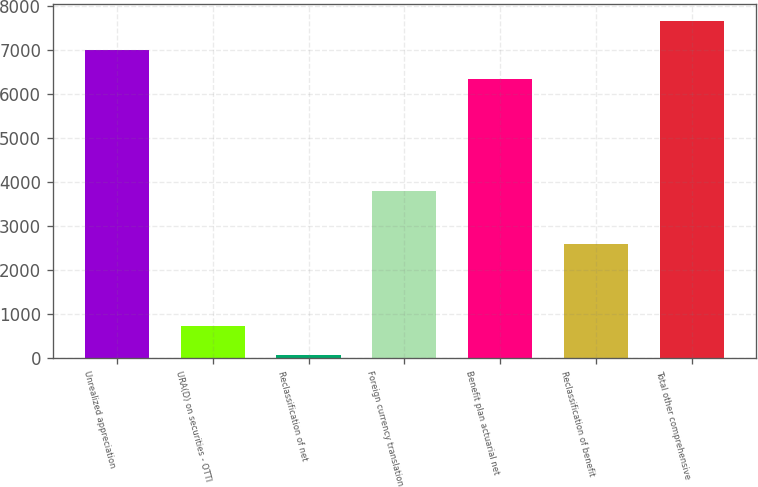Convert chart. <chart><loc_0><loc_0><loc_500><loc_500><bar_chart><fcel>Unrealized appreciation<fcel>URA(D) on securities - OTTI<fcel>Reclassification of net<fcel>Foreign currency translation<fcel>Benefit plan actuarial net<fcel>Reclassification of benefit<fcel>Total other comprehensive<nl><fcel>6997.1<fcel>729.1<fcel>70<fcel>3786<fcel>6338<fcel>2582<fcel>7656.2<nl></chart> 